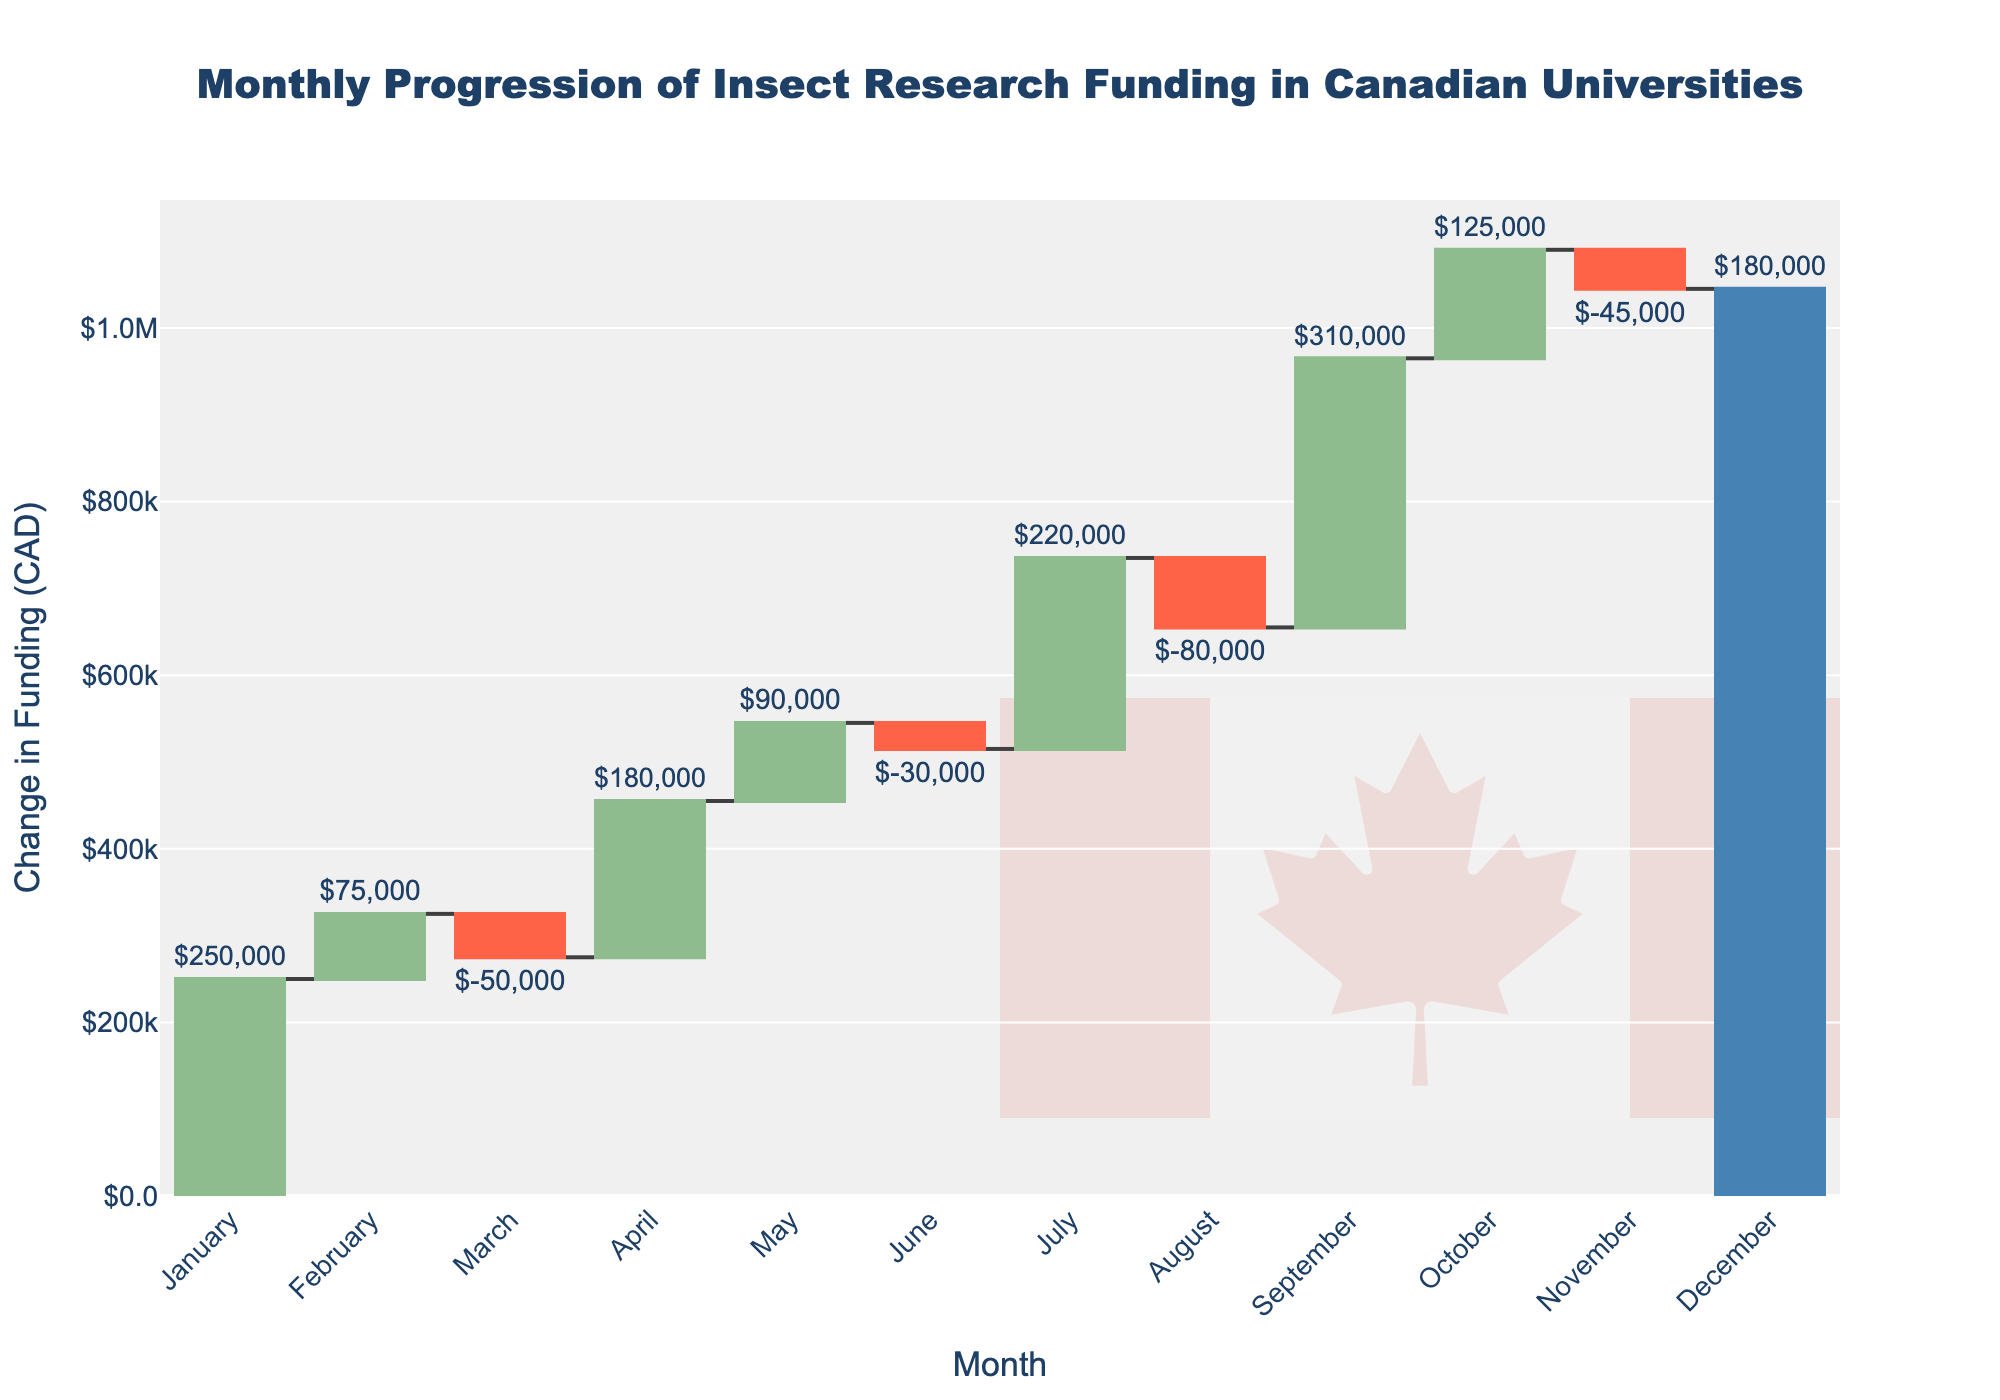What's the total change in research funding in December? The plot's bar for December shows a total increase of $180,000. Therefore, the total change in December is a gain.
Answer: $180,000 Which month had the largest increase in funding? By looking at the waterfall chart, September shows the highest bar, indicating an increase of $310,000.
Answer: September Which month experienced the largest decrease in research funding? The waterfall chart indicates that August had the largest decrease in funding, with a reduction of $80,000.
Answer: August What's the cumulative funding at the end of October? According to the chart, the cumulative funding at the end of October is $1,090,000.
Answer: $1,090,000 How many months had a decrease in funding? There are three months with red bars indicating a decrease: March, June, August, and November.
Answer: 4 What is the cumulative funding at the end of the first quarter (March)? Summing the cumulative changes for January ($250,000), February ($75,000), and March (-$50,000) gives $325,000.
Answer: $275,000 Did the funding increase or decrease more in July compared to February? July had an increase of $220,000, whereas February had an increase of $75,000. Comparing these amounts shows that July had a larger increase.
Answer: Increase more What’s the average monthly funding increase over the entire year? Summing all the monthly changes: $250,000 + $75,000 - $50,000 + $180,000 + $90,000 - $30,000 + $220,000 - $80,000 + $310,000 + $125,000 - $45,000 + $180,000 = $1,225,000. The average increase per month is $1,225,000/12 ≈ $102,083.33.
Answer: Approximately $102,083.33 What’s the total increase in funding during the spring months (March, April, May)? Summing the changes for March (-$50,000), April ($180,000), and May ($90,000) gives a total increase: -$50,000 + $180,000 + $90,000 = $220,000.
Answer: $220,000 